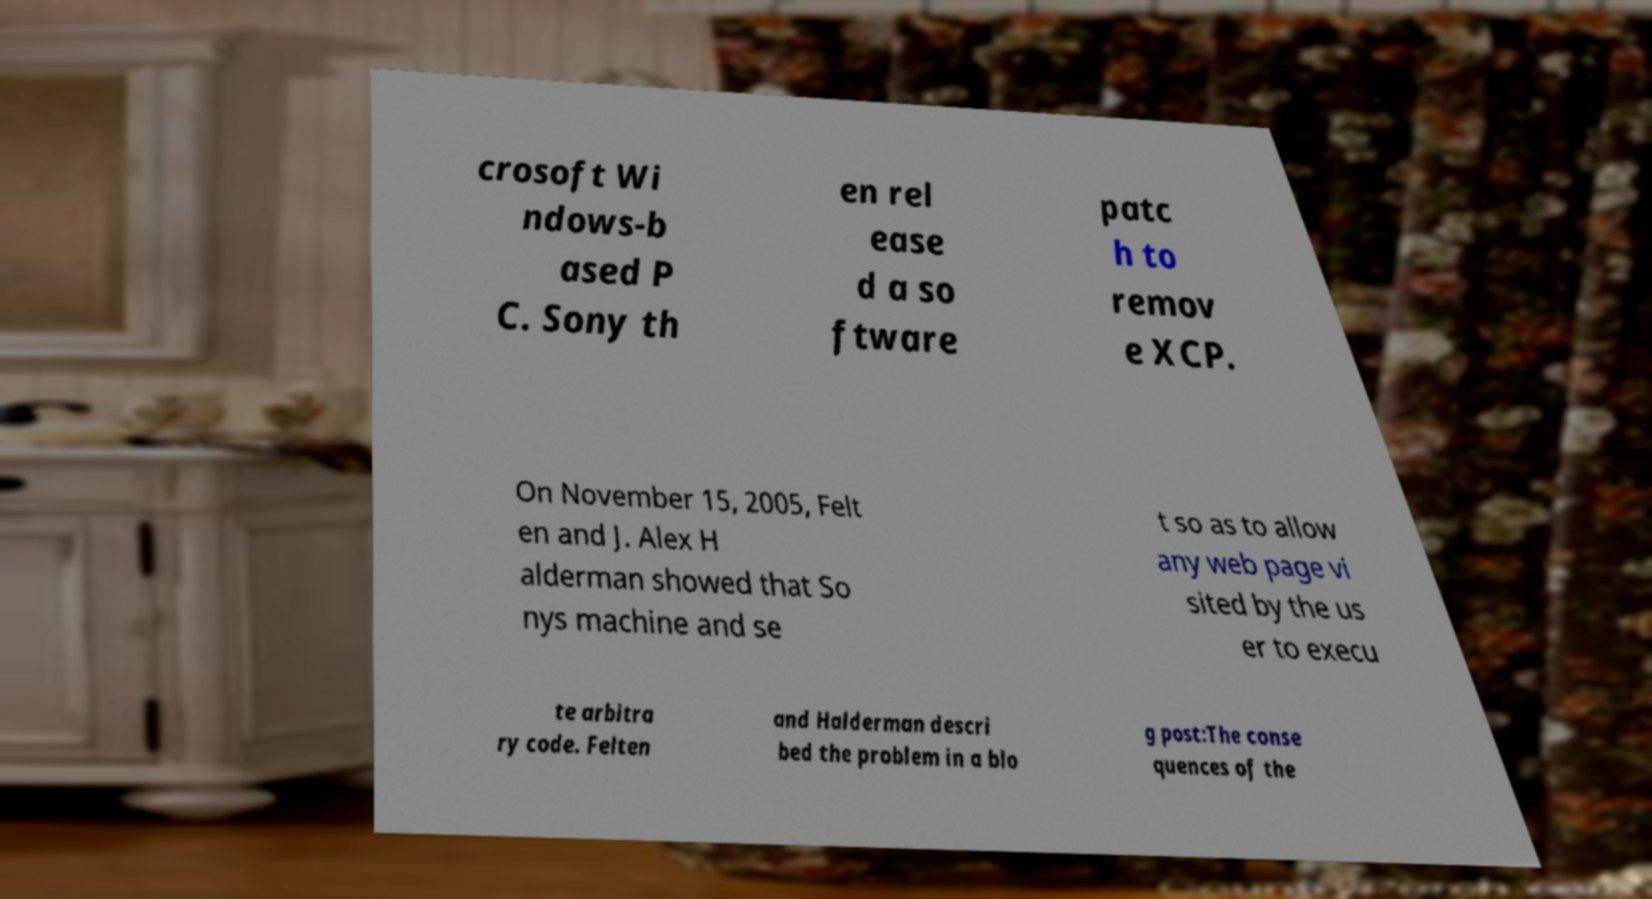Can you read and provide the text displayed in the image?This photo seems to have some interesting text. Can you extract and type it out for me? crosoft Wi ndows-b ased P C. Sony th en rel ease d a so ftware patc h to remov e XCP. On November 15, 2005, Felt en and J. Alex H alderman showed that So nys machine and se t so as to allow any web page vi sited by the us er to execu te arbitra ry code. Felten and Halderman descri bed the problem in a blo g post:The conse quences of the 